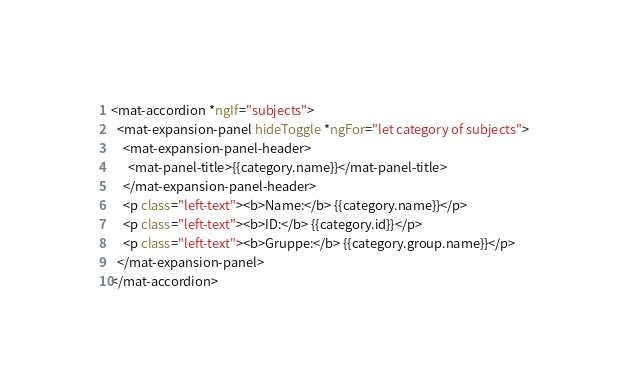Convert code to text. <code><loc_0><loc_0><loc_500><loc_500><_HTML_><mat-accordion *ngIf="subjects">
  <mat-expansion-panel hideToggle *ngFor="let category of subjects">
    <mat-expansion-panel-header>
      <mat-panel-title>{{category.name}}</mat-panel-title>
    </mat-expansion-panel-header>
    <p class="left-text"><b>Name:</b> {{category.name}}</p>
    <p class="left-text"><b>ID:</b> {{category.id}}</p>
    <p class="left-text"><b>Gruppe:</b> {{category.group.name}}</p>
  </mat-expansion-panel>
</mat-accordion>
</code> 